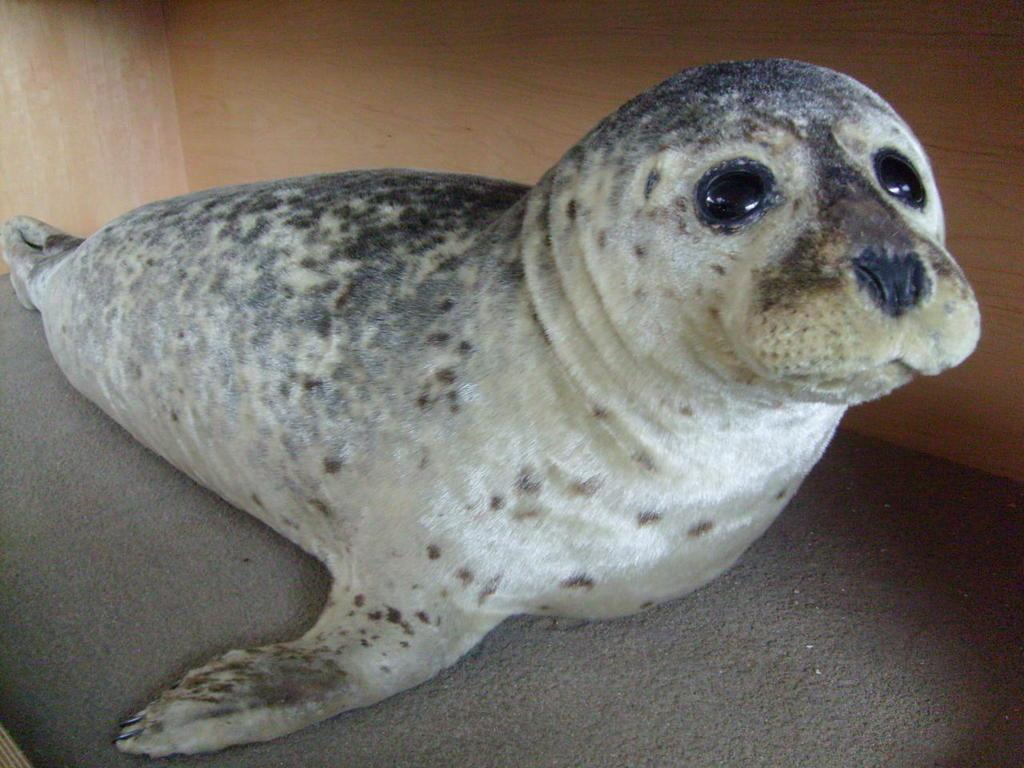What type of animal is in the image? There is a harbor seal in the image. What can be seen in the background of the image? There is a wooden wall in the background of the image. What type of linen is draped over the harbor seal in the image? There is no linen present in the image; the harbor seal is not covered by any fabric. 